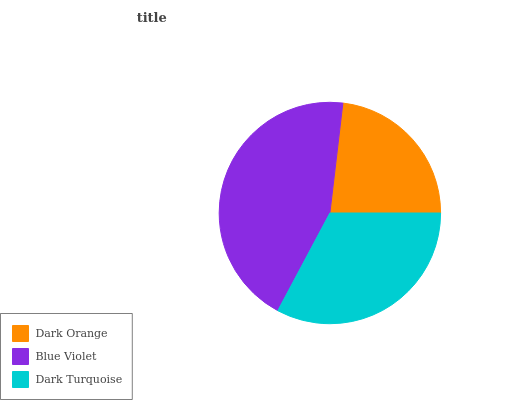Is Dark Orange the minimum?
Answer yes or no. Yes. Is Blue Violet the maximum?
Answer yes or no. Yes. Is Dark Turquoise the minimum?
Answer yes or no. No. Is Dark Turquoise the maximum?
Answer yes or no. No. Is Blue Violet greater than Dark Turquoise?
Answer yes or no. Yes. Is Dark Turquoise less than Blue Violet?
Answer yes or no. Yes. Is Dark Turquoise greater than Blue Violet?
Answer yes or no. No. Is Blue Violet less than Dark Turquoise?
Answer yes or no. No. Is Dark Turquoise the high median?
Answer yes or no. Yes. Is Dark Turquoise the low median?
Answer yes or no. Yes. Is Dark Orange the high median?
Answer yes or no. No. Is Blue Violet the low median?
Answer yes or no. No. 